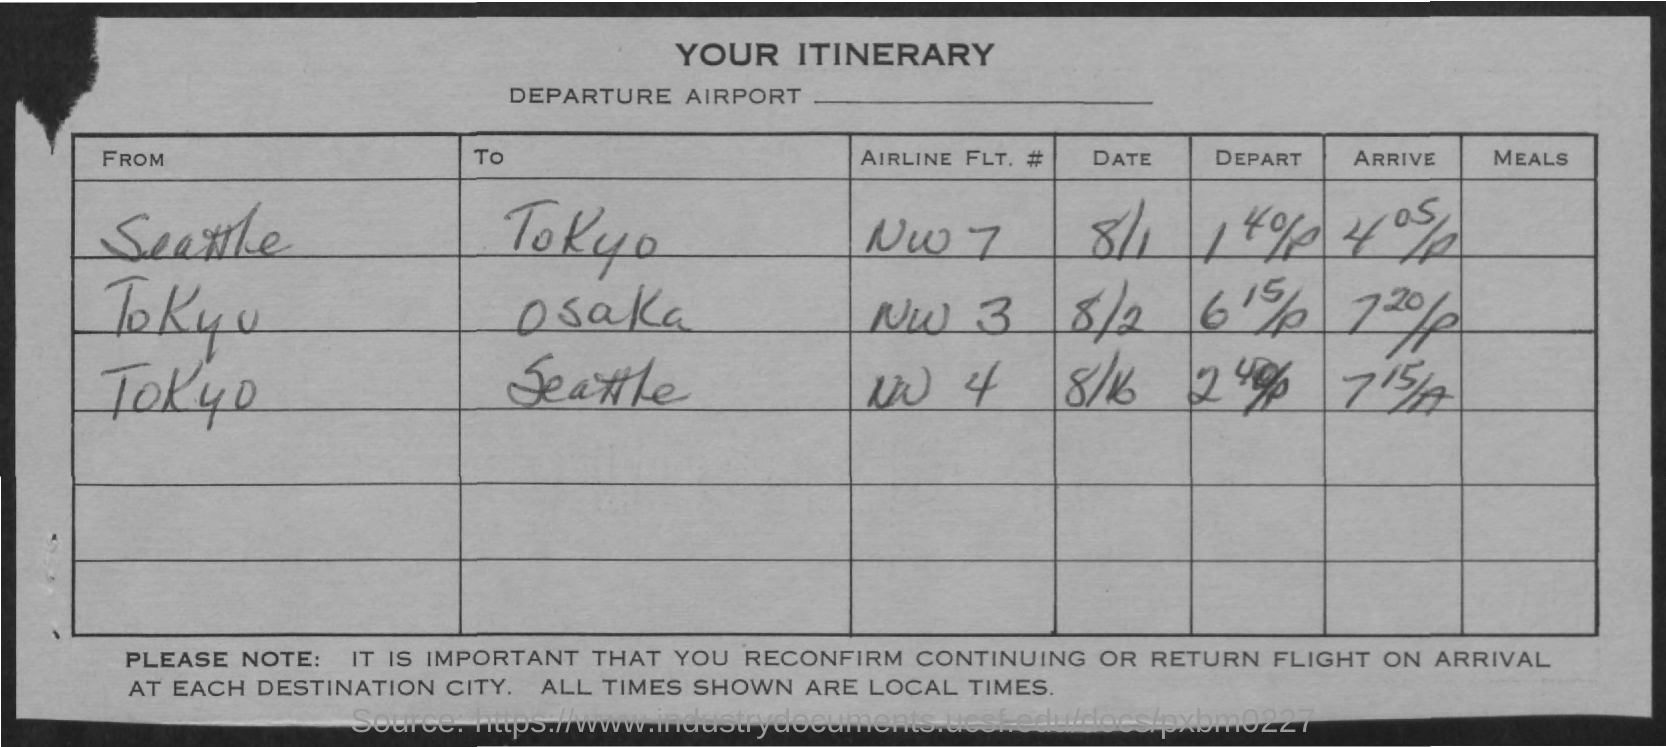What is the airline flt. # from seattle to tokyo ?
Make the answer very short. NW 7. What is the airline flt.# from tokyo to seattle ?
Keep it short and to the point. NW 4. What is the airline flt.# from tokyo to osaka ??
Give a very brief answer. NW 3. On which date airline flt.# nw 3 was there from tokyo to osaka ?
Make the answer very short. 8/2. On which date airline flt.# nw 4 was there from tokyo to seattle?
Provide a succinct answer. 8/16. 